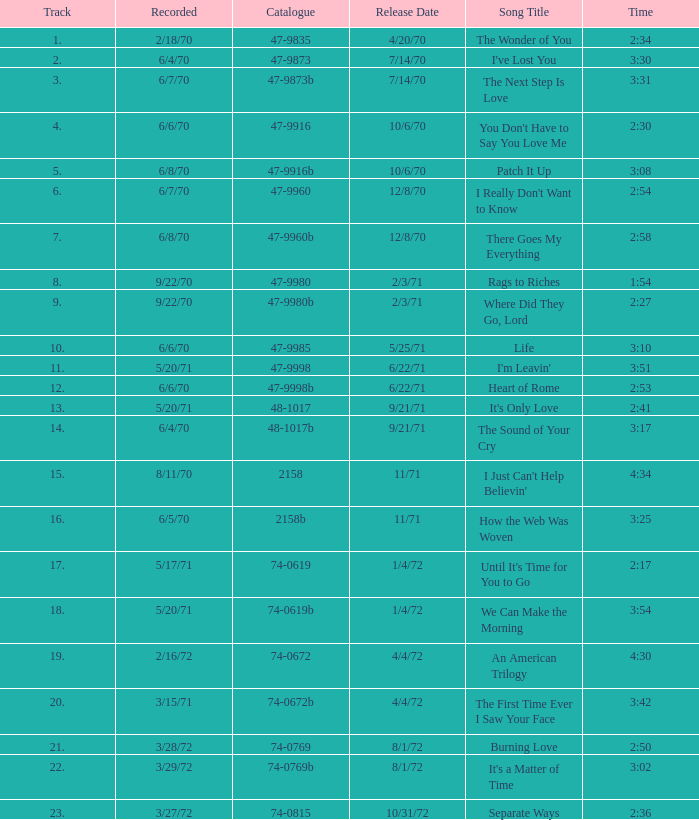What is Heart of Rome's catalogue number? 47-9998b. 